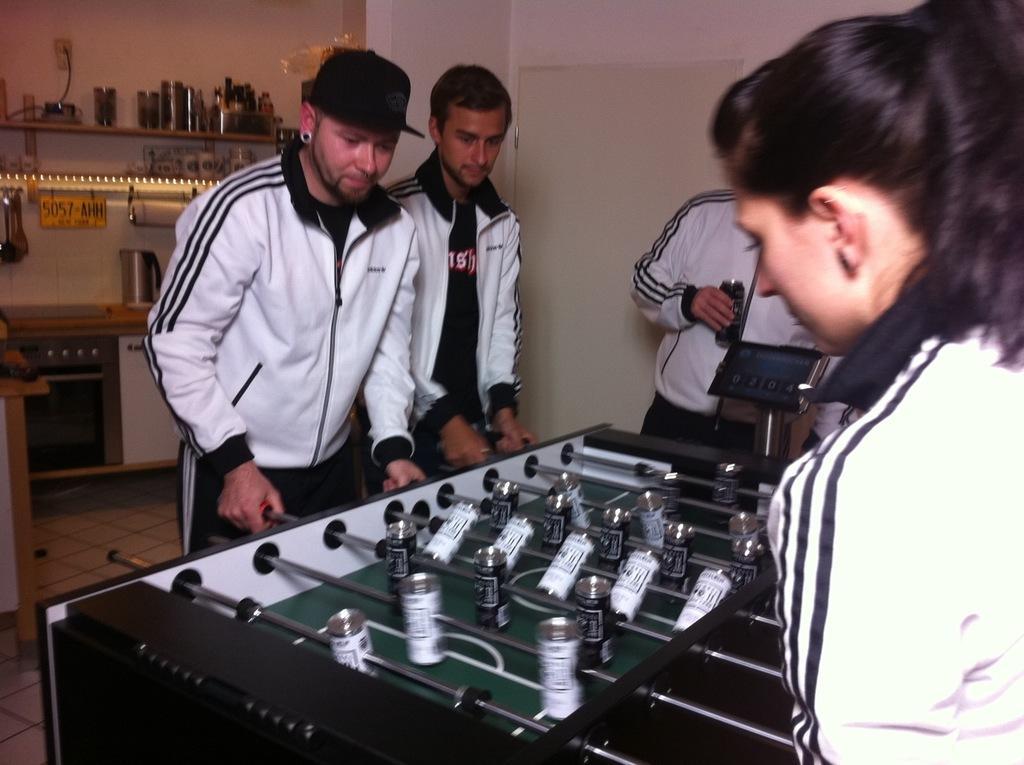Describe this image in one or two sentences. This picture describes about group of people, and few people are playing table football, in the background we can see few lights, oven and other things. 